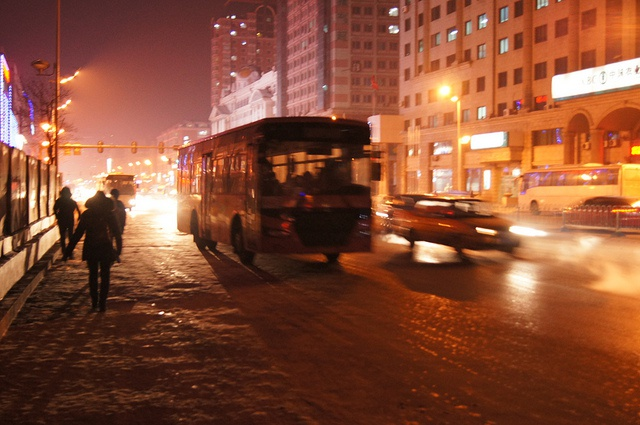Describe the objects in this image and their specific colors. I can see bus in maroon, black, and brown tones, car in maroon, black, and brown tones, bus in maroon, orange, gold, and red tones, people in maroon, black, and brown tones, and bus in maroon, brown, tan, and red tones in this image. 